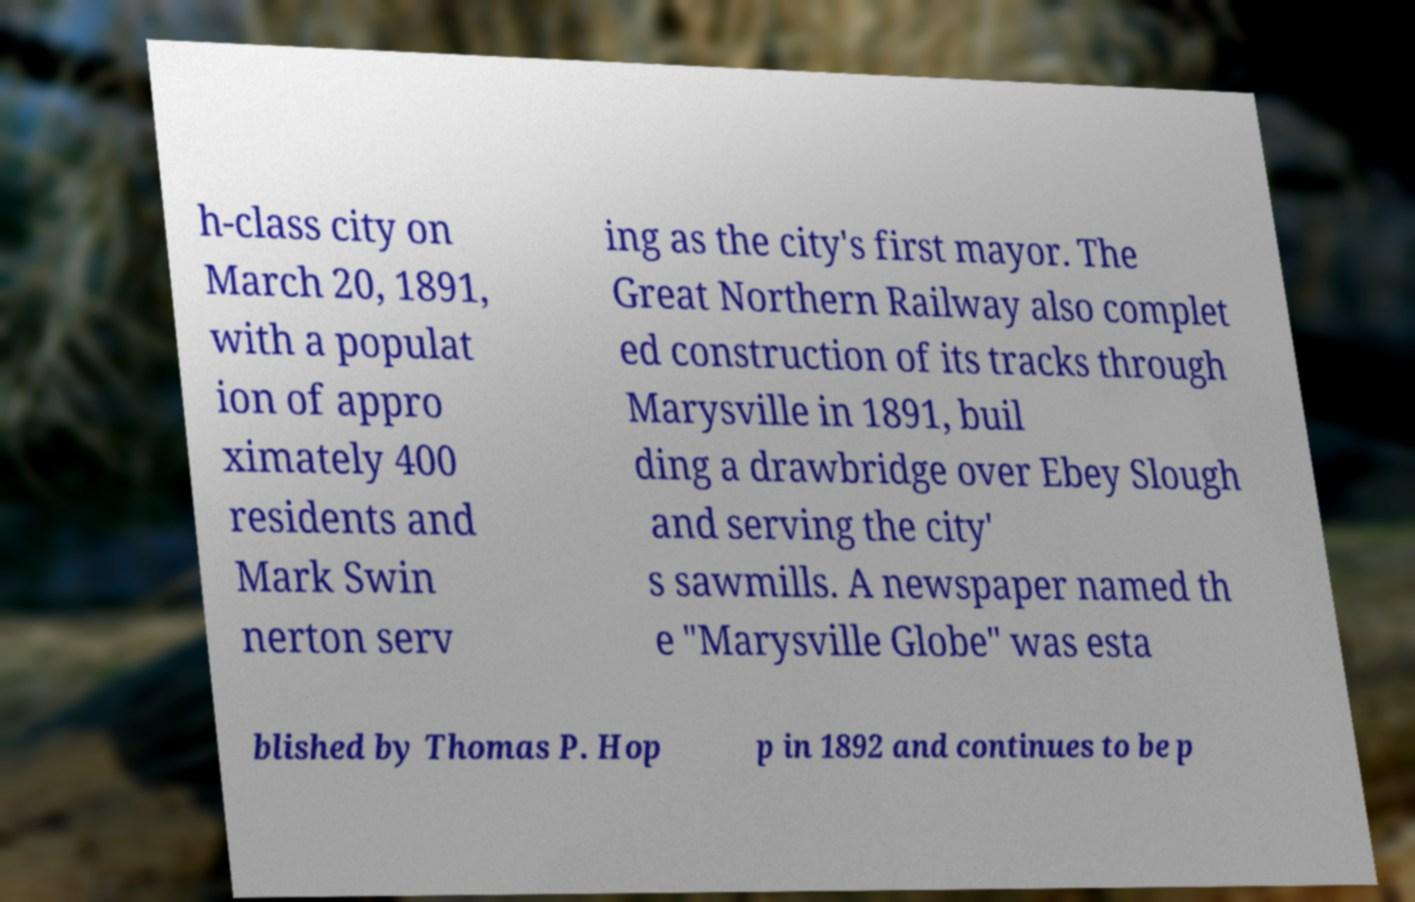Please identify and transcribe the text found in this image. h-class city on March 20, 1891, with a populat ion of appro ximately 400 residents and Mark Swin nerton serv ing as the city's first mayor. The Great Northern Railway also complet ed construction of its tracks through Marysville in 1891, buil ding a drawbridge over Ebey Slough and serving the city' s sawmills. A newspaper named th e "Marysville Globe" was esta blished by Thomas P. Hop p in 1892 and continues to be p 